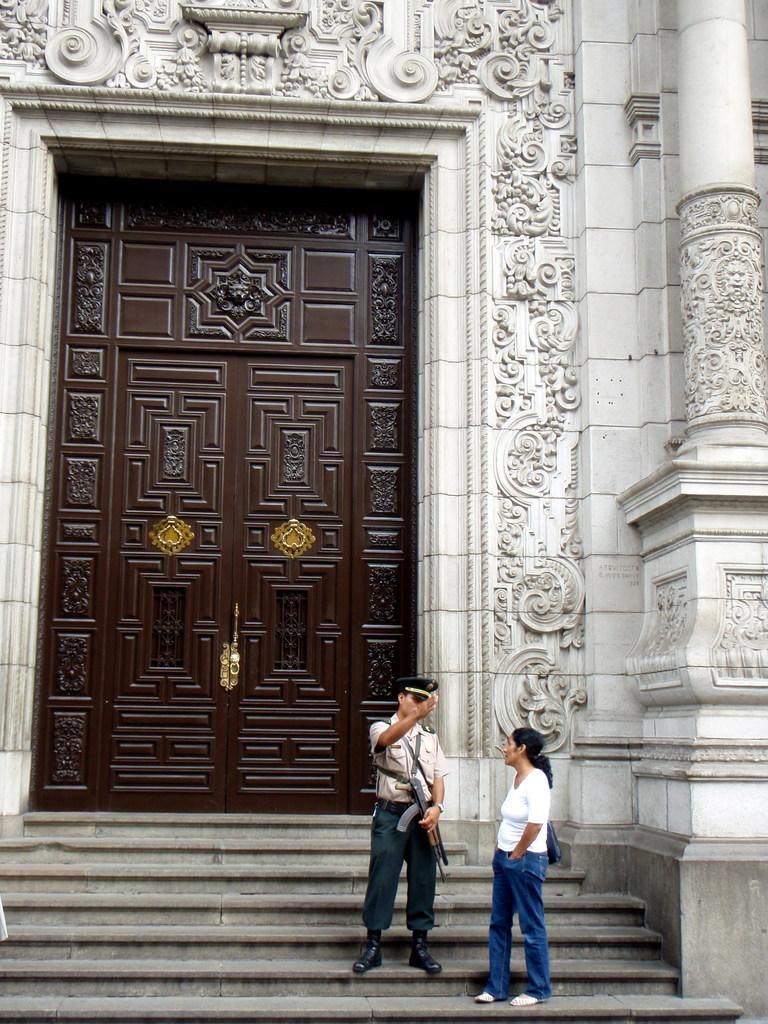What are the people in the image doing? The persons in the image are standing on the staircase. Can you describe what one of the persons is holding? One of the persons is holding a gun in their hand. What can be seen in the background of the image? There is a door visible in the background, as well as sculptures on the wall and pillars. What type of note is being passed between the persons on the staircase? There is no note being passed between the persons in the image; one of them is holding a gun. What is the chance of finding milk in the image? There is no milk present in the image. 